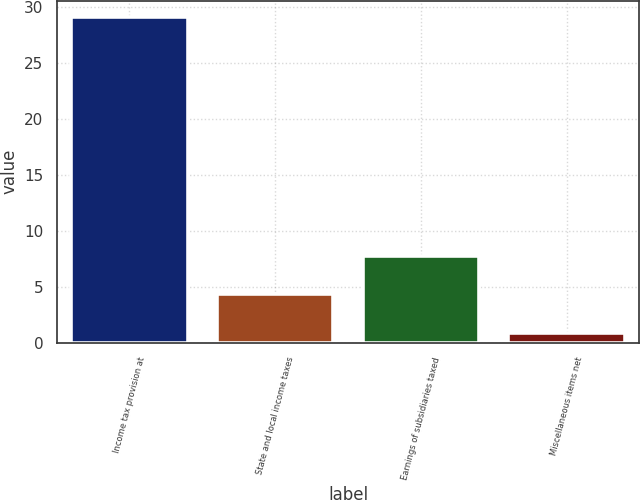Convert chart to OTSL. <chart><loc_0><loc_0><loc_500><loc_500><bar_chart><fcel>Income tax provision at<fcel>State and local income taxes<fcel>Earnings of subsidiaries taxed<fcel>Miscellaneous items net<nl><fcel>29.1<fcel>4.31<fcel>7.72<fcel>0.9<nl></chart> 